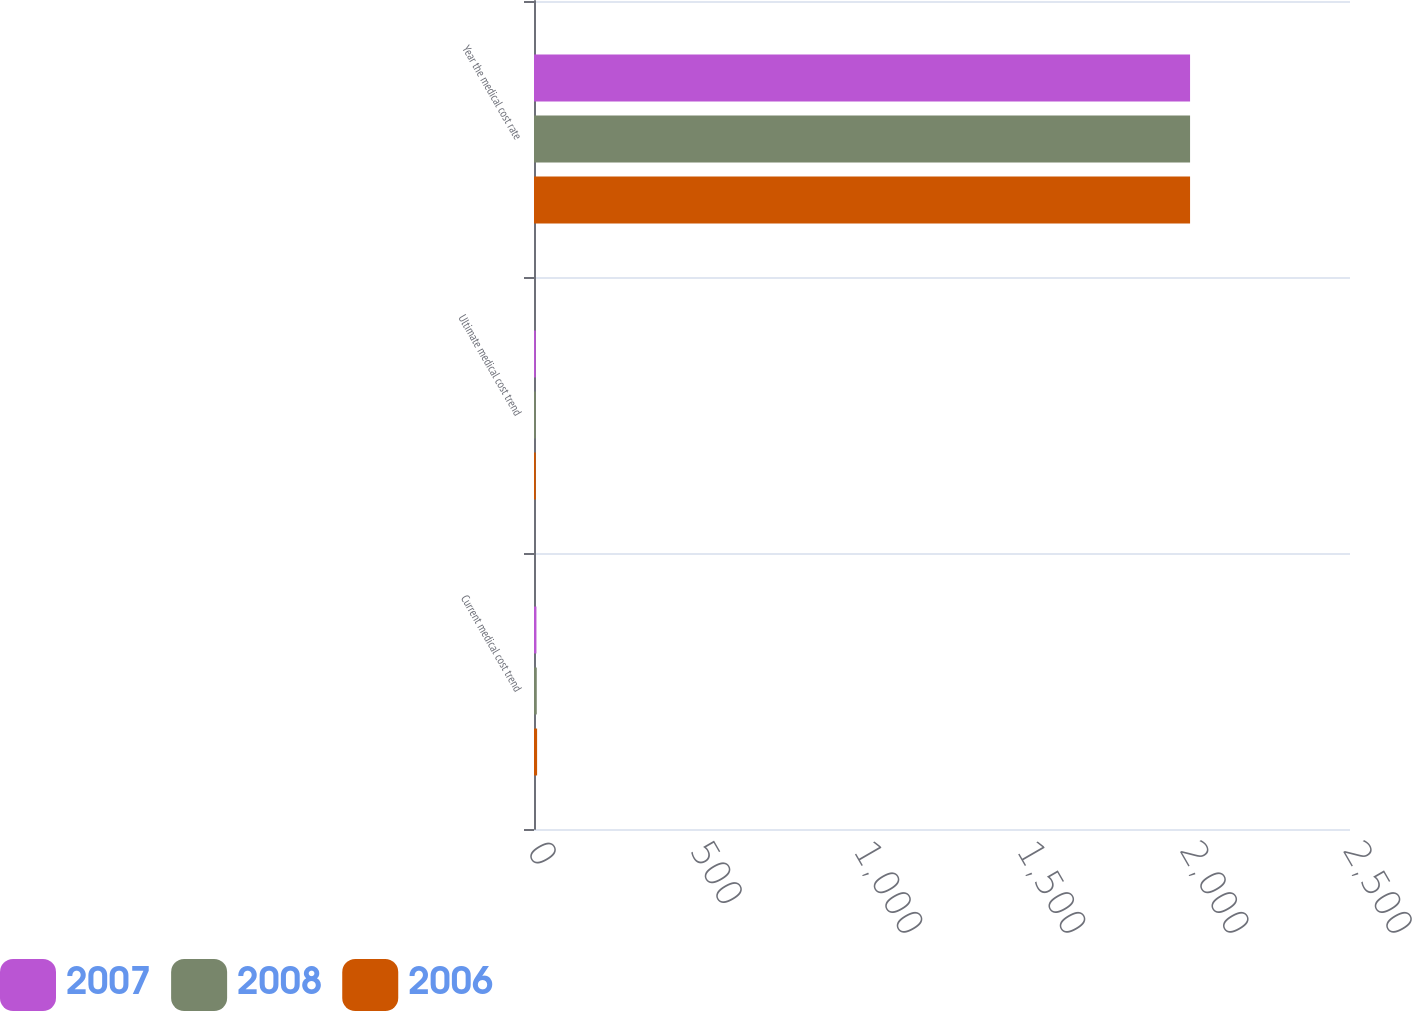Convert chart. <chart><loc_0><loc_0><loc_500><loc_500><stacked_bar_chart><ecel><fcel>Current medical cost trend<fcel>Ultimate medical cost trend<fcel>Year the medical cost rate<nl><fcel>2007<fcel>7.5<fcel>5.5<fcel>2010<nl><fcel>2008<fcel>8.5<fcel>5.5<fcel>2010<nl><fcel>2006<fcel>9.5<fcel>5.5<fcel>2010<nl></chart> 